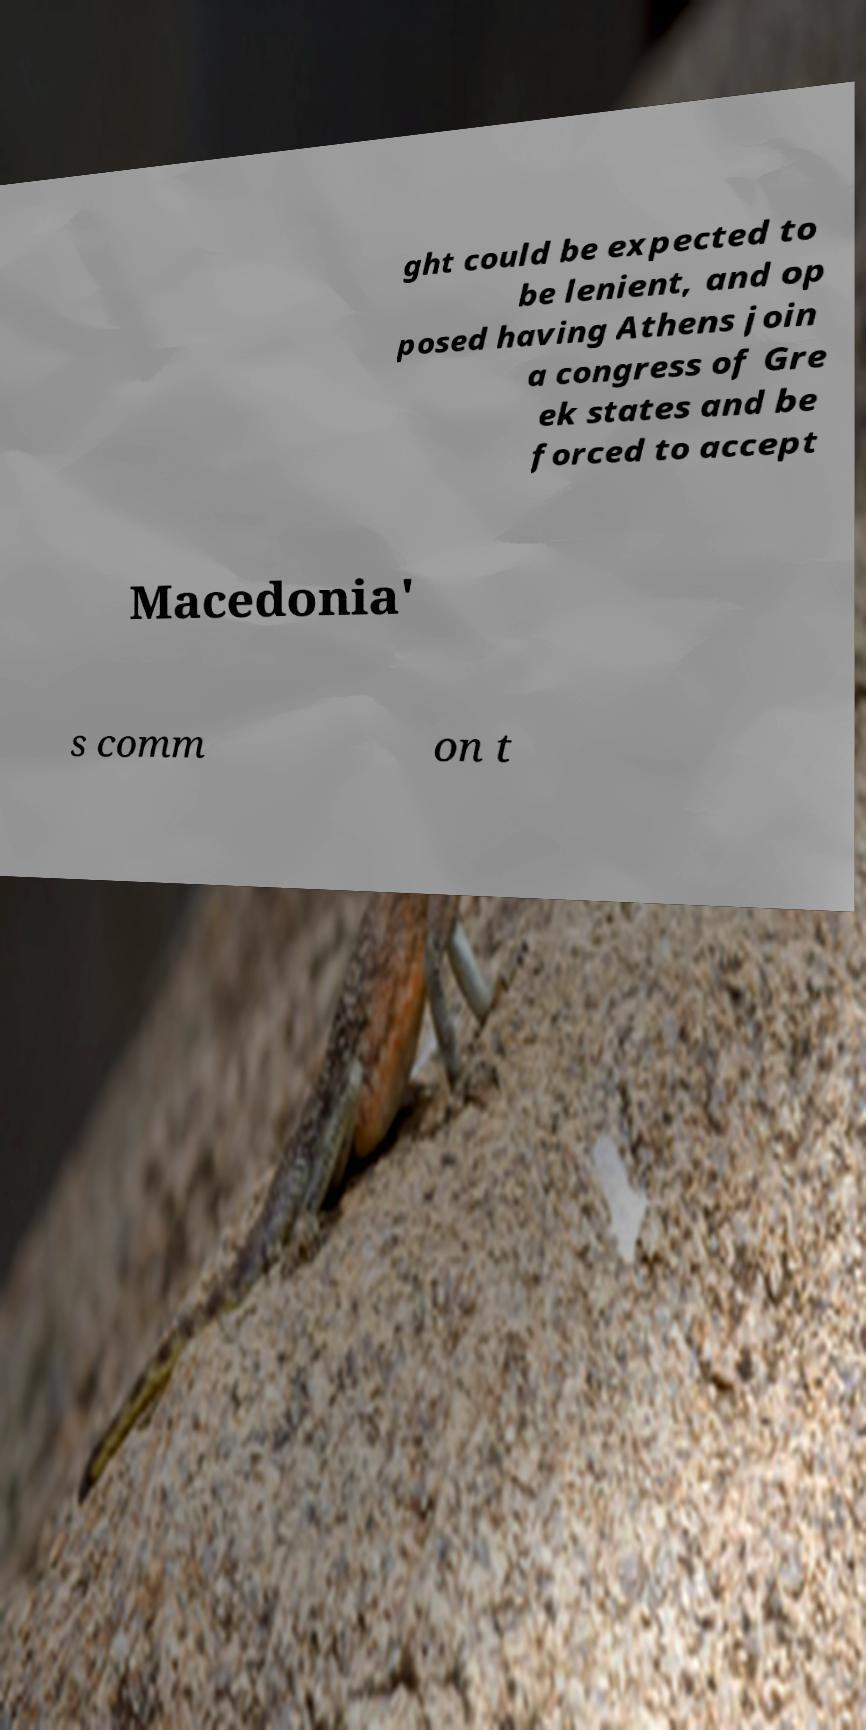For documentation purposes, I need the text within this image transcribed. Could you provide that? ght could be expected to be lenient, and op posed having Athens join a congress of Gre ek states and be forced to accept Macedonia' s comm on t 